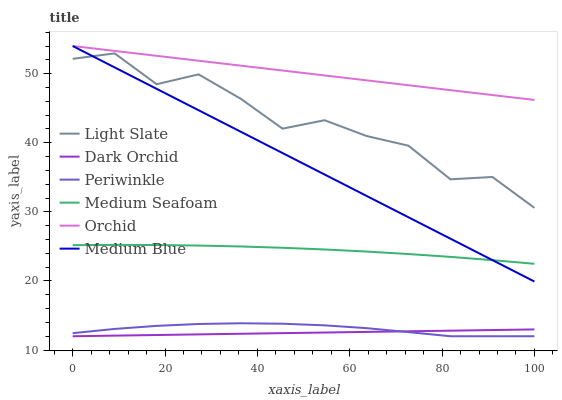Does Dark Orchid have the minimum area under the curve?
Answer yes or no. Yes. Does Orchid have the maximum area under the curve?
Answer yes or no. Yes. Does Medium Blue have the minimum area under the curve?
Answer yes or no. No. Does Medium Blue have the maximum area under the curve?
Answer yes or no. No. Is Dark Orchid the smoothest?
Answer yes or no. Yes. Is Light Slate the roughest?
Answer yes or no. Yes. Is Medium Blue the smoothest?
Answer yes or no. No. Is Medium Blue the roughest?
Answer yes or no. No. Does Dark Orchid have the lowest value?
Answer yes or no. Yes. Does Medium Blue have the lowest value?
Answer yes or no. No. Does Orchid have the highest value?
Answer yes or no. Yes. Does Dark Orchid have the highest value?
Answer yes or no. No. Is Medium Seafoam less than Light Slate?
Answer yes or no. Yes. Is Medium Seafoam greater than Dark Orchid?
Answer yes or no. Yes. Does Dark Orchid intersect Periwinkle?
Answer yes or no. Yes. Is Dark Orchid less than Periwinkle?
Answer yes or no. No. Is Dark Orchid greater than Periwinkle?
Answer yes or no. No. Does Medium Seafoam intersect Light Slate?
Answer yes or no. No. 